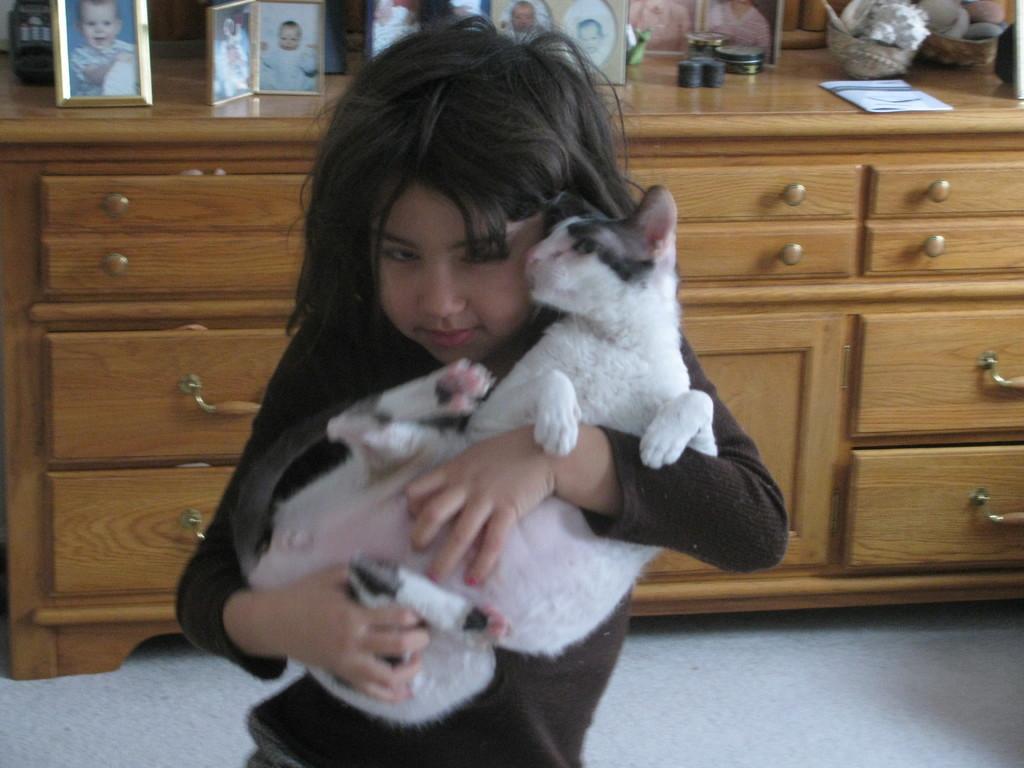How would you summarize this image in a sentence or two? This image is taken inside the room where a girl is standing in the center and holding puppies in her hand. In the background there is a table and photo frames are kept on this table. At the right side on the table there are baskets and paper. 